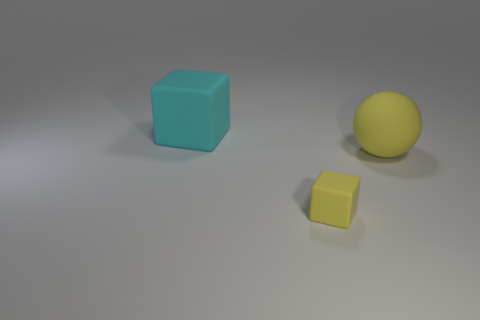There is a matte cube to the left of the tiny thing; is it the same size as the matte block that is right of the large cyan object?
Offer a terse response. No. There is a yellow matte object behind the rubber cube that is in front of the cyan thing; what is its shape?
Provide a short and direct response. Sphere. Is the number of small matte blocks that are in front of the large yellow rubber ball the same as the number of small things?
Provide a succinct answer. Yes. There is a yellow object behind the cube that is in front of the large rubber thing that is left of the tiny yellow rubber cube; what is its material?
Your answer should be compact. Rubber. Are there any balls that have the same size as the cyan matte block?
Make the answer very short. Yes. What is the shape of the small matte object?
Your answer should be compact. Cube. How many balls are either large objects or tiny objects?
Give a very brief answer. 1. Are there the same number of small matte cubes to the right of the yellow rubber sphere and tiny blocks behind the small block?
Offer a very short reply. Yes. There is a large object that is to the left of the large matte thing right of the big cyan object; how many tiny yellow blocks are behind it?
Ensure brevity in your answer.  0. The other matte object that is the same color as the small thing is what shape?
Provide a short and direct response. Sphere. 